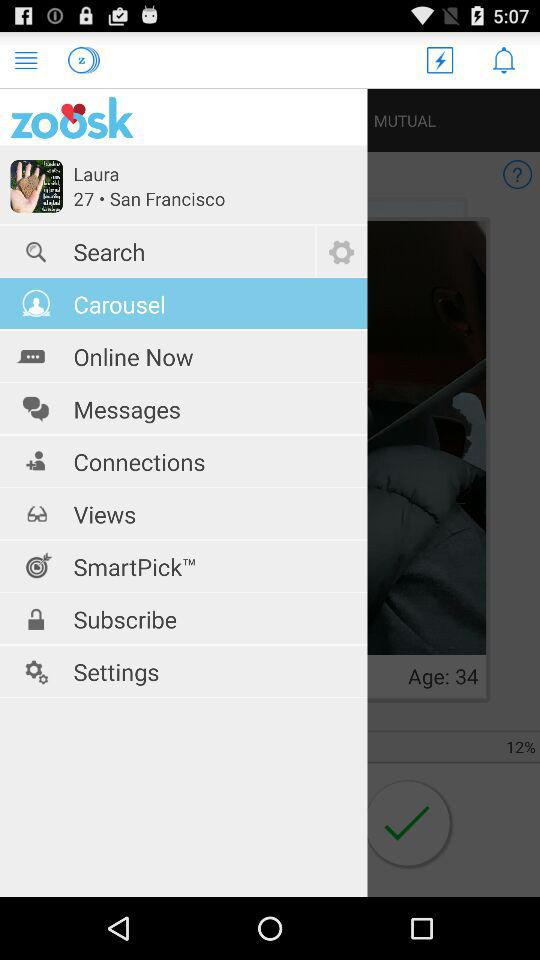How many unread messages are there?
When the provided information is insufficient, respond with <no answer>. <no answer> 